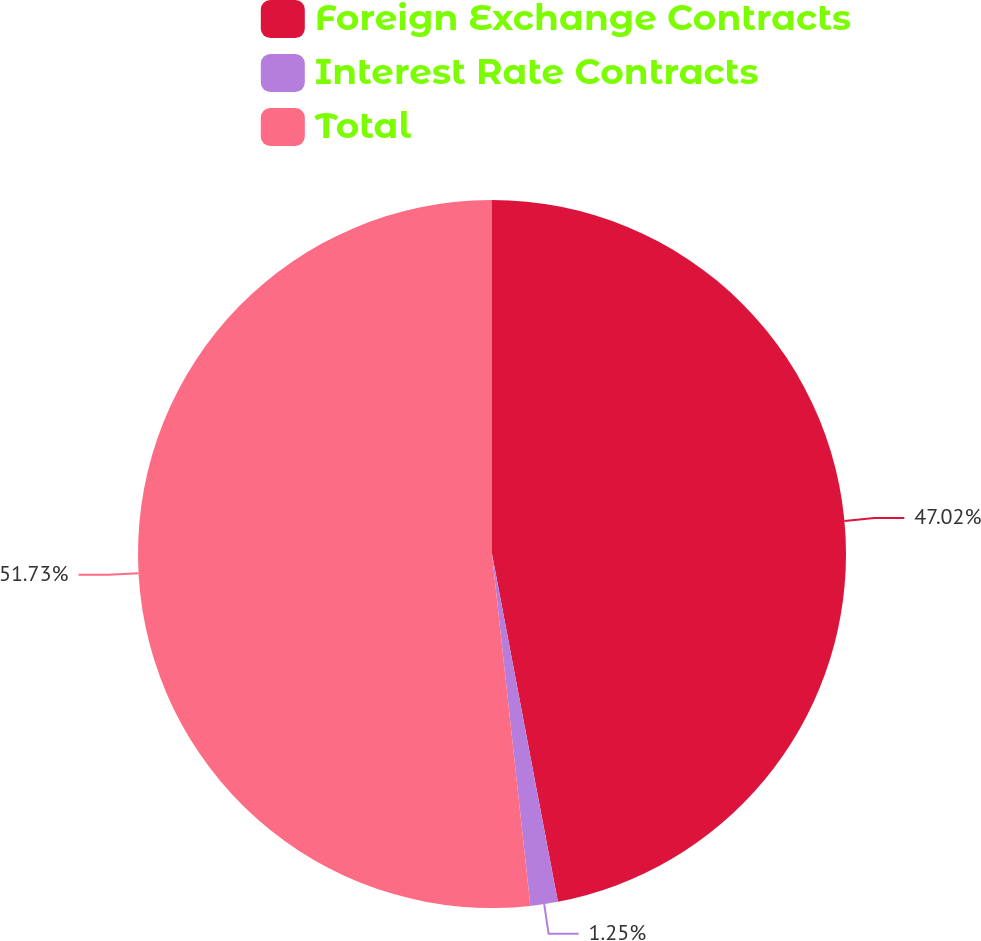<chart> <loc_0><loc_0><loc_500><loc_500><pie_chart><fcel>Foreign Exchange Contracts<fcel>Interest Rate Contracts<fcel>Total<nl><fcel>47.02%<fcel>1.25%<fcel>51.73%<nl></chart> 